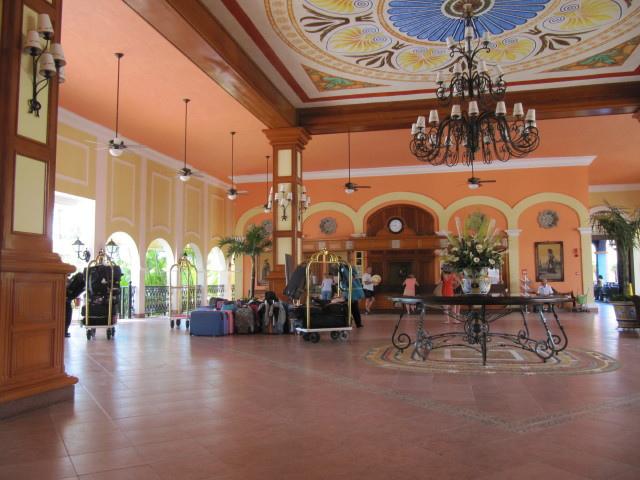What amount of round lights are hanging from the ceiling?
Quick response, please. 6. What is the style of artwork on the ceiling called?
Give a very brief answer. Mural. How many bags of luggage are there?
Be succinct. Many. 